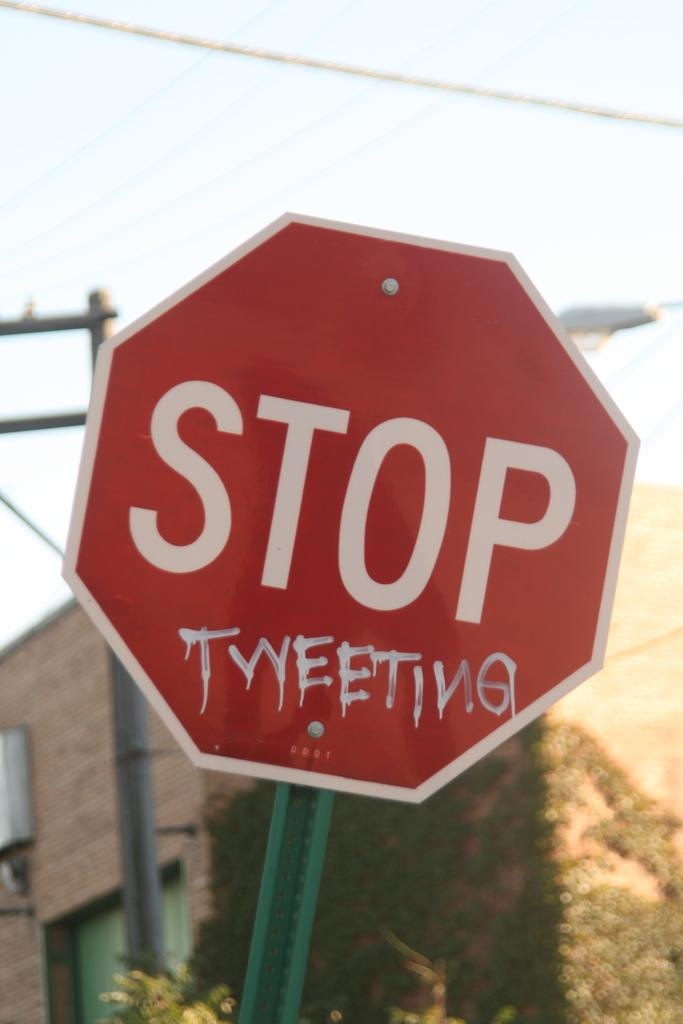<image>
Present a compact description of the photo's key features. a stop sign that is outside with a building behind 